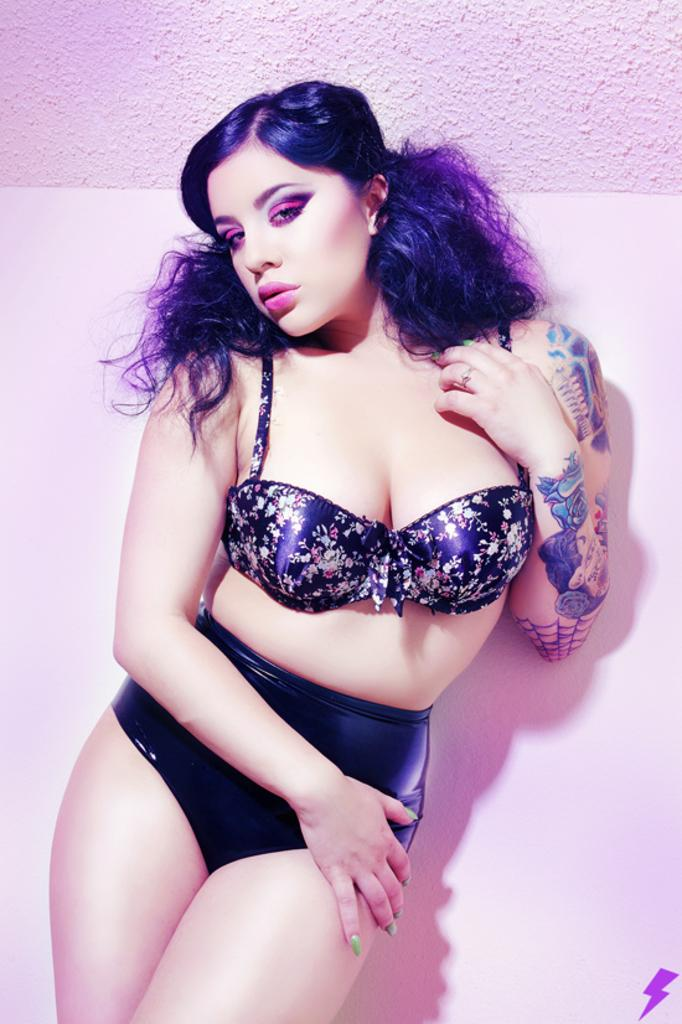What is the main subject of the image? There is a person standing in the image. Can you describe the background of the image? There is a wall visible in the background of the image. The wall appears to be truncated. What type of rifle is the person holding in the image? There is no rifle present in the image; the person is simply standing. What kind of experience does the person have with pests in the image? There is no indication of any pests or experiences with pests in the image. 